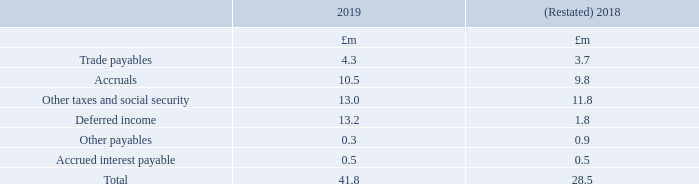20. Trade and other payables
Following the application of IFRS 16, trade and other payables for the year ended 31 March 2018 have been restated (note 2).
Trade payables are unsecured and are usually paid within 30 days of recognition. The carrying amounts of trade and other payables are considered to be the same as their fair values, due to their short-term nature.
When are trade payables paid? Within 30 days of recognition. Why are trade payables in 2018 restated in the table? Following the application of ifrs 16. In which years were the components in trade and other payables calculated in? 2019, 2018. In which year were Trade payables larger? 4.3>3.7
Answer: 2019. What was the change in trade payables in 2019 from 2018?
Answer scale should be: million. 4.3-3.7
Answer: 0.6. What was the percentage change in trade payables in 2019 from 2018?
Answer scale should be: percent. (4.3-3.7)/3.7
Answer: 16.22. 